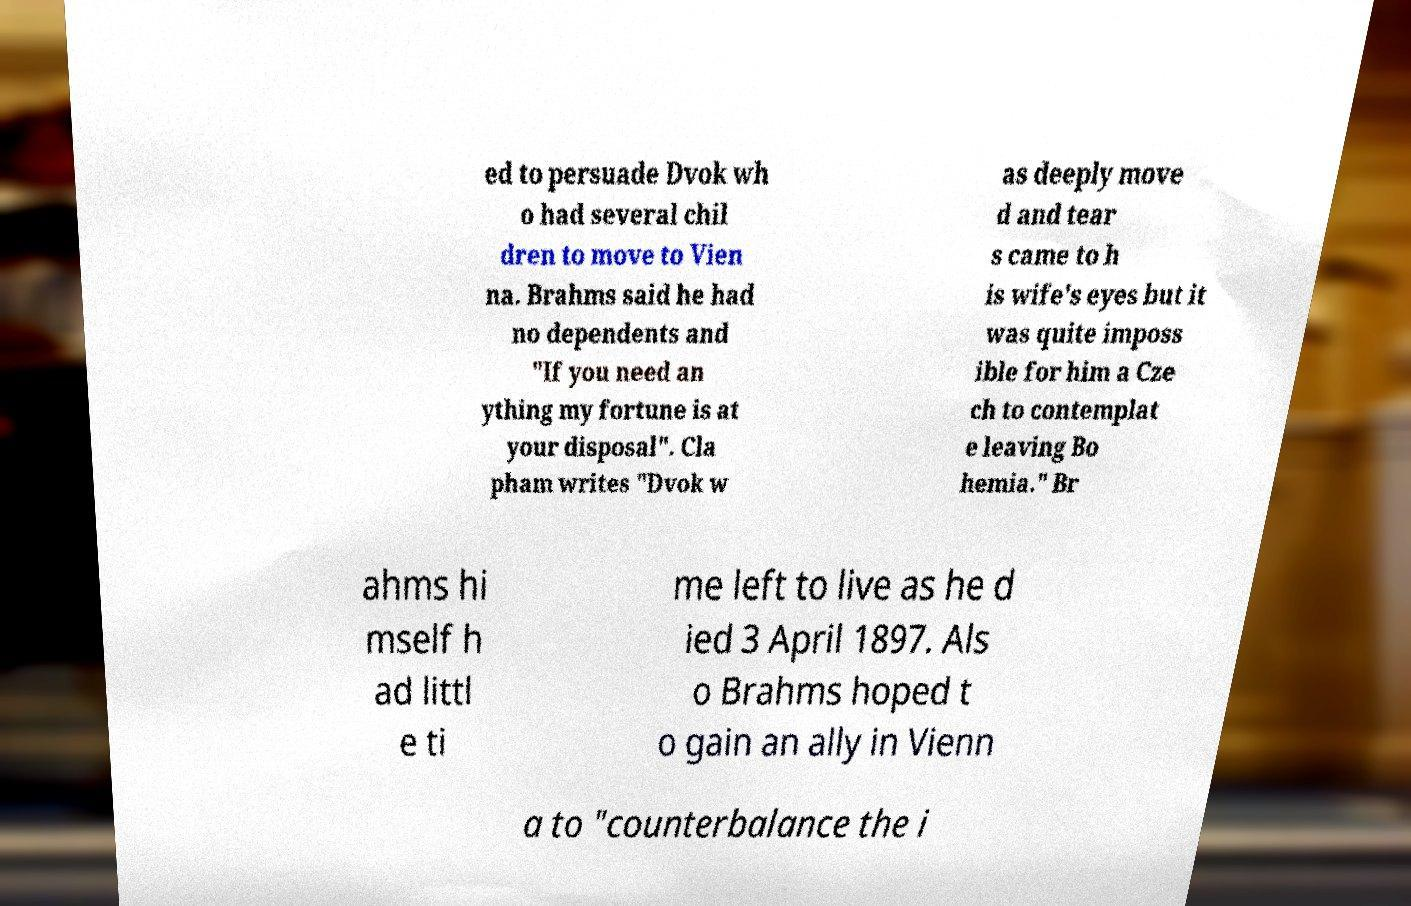Could you extract and type out the text from this image? ed to persuade Dvok wh o had several chil dren to move to Vien na. Brahms said he had no dependents and "If you need an ything my fortune is at your disposal". Cla pham writes "Dvok w as deeply move d and tear s came to h is wife's eyes but it was quite imposs ible for him a Cze ch to contemplat e leaving Bo hemia." Br ahms hi mself h ad littl e ti me left to live as he d ied 3 April 1897. Als o Brahms hoped t o gain an ally in Vienn a to "counterbalance the i 